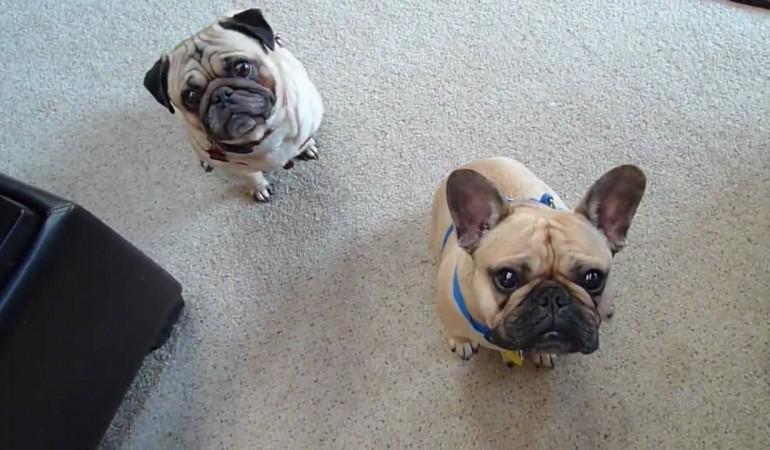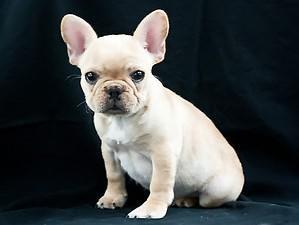The first image is the image on the left, the second image is the image on the right. For the images displayed, is the sentence "The dog in the image on the right is standing on all fours." factually correct? Answer yes or no. No. The first image is the image on the left, the second image is the image on the right. Assess this claim about the two images: "One image shows a sitting dog with pale coloring, and the other includes at least one tan dog with a dark muzzle who is wearing a collar.". Correct or not? Answer yes or no. Yes. 